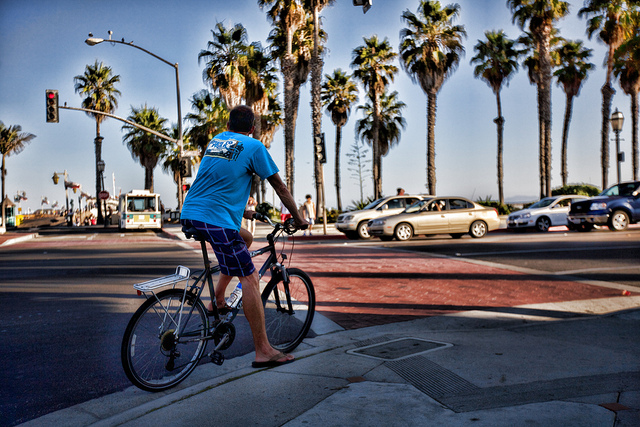Can you describe the weather or atmosphere in the scene depicted in the image? The atmosphere in the image appears to be warm and sunny, with clear blue skies and no evidence of precipitation. The presence of palm trees and individuals dressed in summer attire suggest the climate is quite pleasant and likely conducive to outdoor activities such as cycling. 